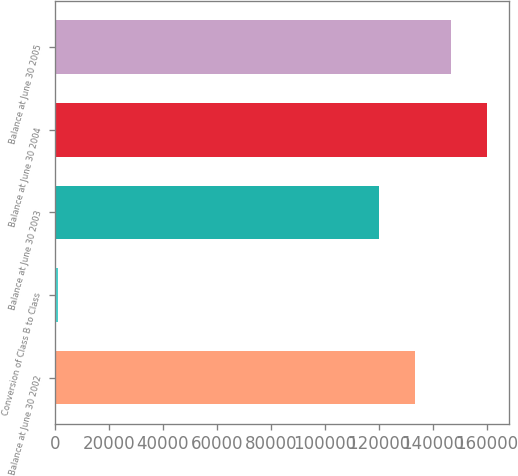Convert chart to OTSL. <chart><loc_0><loc_0><loc_500><loc_500><bar_chart><fcel>Balance at June 30 2002<fcel>Conversion of Class B to Class<fcel>Balance at June 30 2003<fcel>Balance at June 30 2004<fcel>Balance at June 30 2005<nl><fcel>133350<fcel>950<fcel>119994<fcel>160063<fcel>146707<nl></chart> 